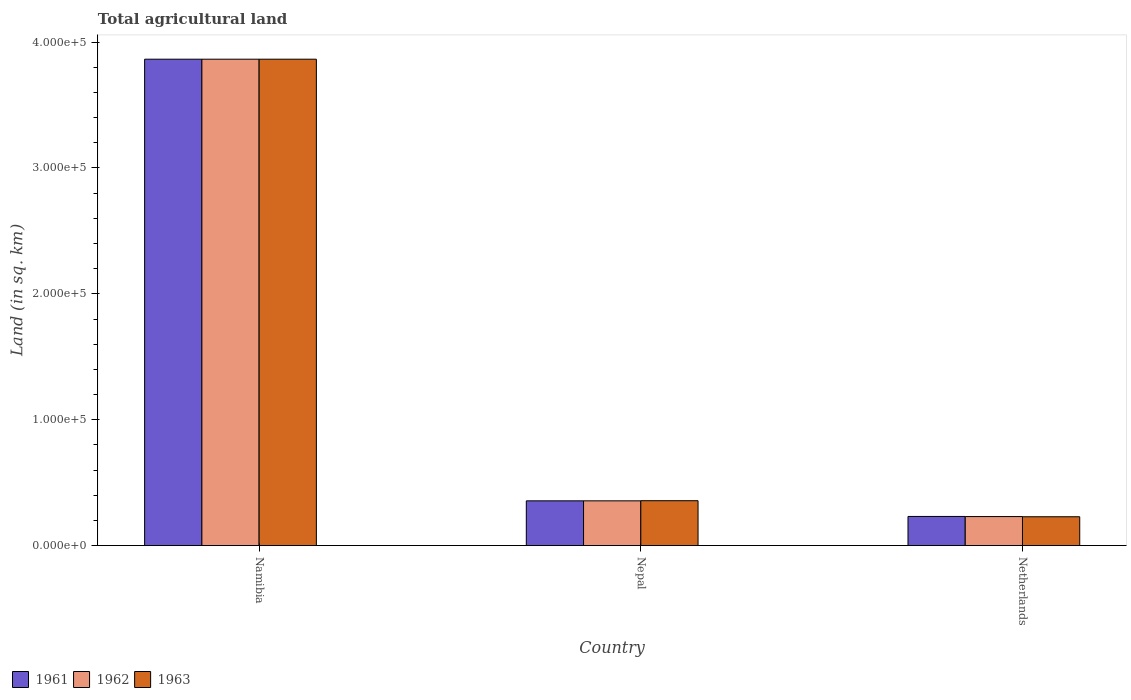How many different coloured bars are there?
Your answer should be compact. 3. How many groups of bars are there?
Your response must be concise. 3. Are the number of bars per tick equal to the number of legend labels?
Keep it short and to the point. Yes. Are the number of bars on each tick of the X-axis equal?
Give a very brief answer. Yes. How many bars are there on the 1st tick from the left?
Provide a succinct answer. 3. What is the label of the 1st group of bars from the left?
Give a very brief answer. Namibia. What is the total agricultural land in 1961 in Namibia?
Provide a succinct answer. 3.86e+05. Across all countries, what is the maximum total agricultural land in 1962?
Your answer should be compact. 3.86e+05. Across all countries, what is the minimum total agricultural land in 1961?
Your answer should be very brief. 2.31e+04. In which country was the total agricultural land in 1961 maximum?
Provide a short and direct response. Namibia. In which country was the total agricultural land in 1963 minimum?
Offer a very short reply. Netherlands. What is the total total agricultural land in 1961 in the graph?
Your response must be concise. 4.45e+05. What is the difference between the total agricultural land in 1962 in Namibia and that in Nepal?
Your answer should be very brief. 3.51e+05. What is the difference between the total agricultural land in 1963 in Nepal and the total agricultural land in 1962 in Namibia?
Provide a succinct answer. -3.51e+05. What is the average total agricultural land in 1961 per country?
Make the answer very short. 1.48e+05. In how many countries, is the total agricultural land in 1962 greater than 180000 sq.km?
Ensure brevity in your answer.  1. What is the ratio of the total agricultural land in 1961 in Namibia to that in Nepal?
Keep it short and to the point. 10.88. Is the total agricultural land in 1962 in Nepal less than that in Netherlands?
Ensure brevity in your answer.  No. Is the difference between the total agricultural land in 1961 in Namibia and Nepal greater than the difference between the total agricultural land in 1962 in Namibia and Nepal?
Your answer should be very brief. No. What is the difference between the highest and the second highest total agricultural land in 1962?
Give a very brief answer. -3.51e+05. What is the difference between the highest and the lowest total agricultural land in 1961?
Give a very brief answer. 3.63e+05. In how many countries, is the total agricultural land in 1963 greater than the average total agricultural land in 1963 taken over all countries?
Offer a very short reply. 1. Is the sum of the total agricultural land in 1961 in Nepal and Netherlands greater than the maximum total agricultural land in 1962 across all countries?
Make the answer very short. No. How many bars are there?
Your answer should be compact. 9. What is the difference between two consecutive major ticks on the Y-axis?
Your answer should be compact. 1.00e+05. How many legend labels are there?
Provide a succinct answer. 3. How are the legend labels stacked?
Ensure brevity in your answer.  Horizontal. What is the title of the graph?
Offer a terse response. Total agricultural land. Does "2011" appear as one of the legend labels in the graph?
Your answer should be compact. No. What is the label or title of the X-axis?
Make the answer very short. Country. What is the label or title of the Y-axis?
Your answer should be compact. Land (in sq. km). What is the Land (in sq. km) of 1961 in Namibia?
Ensure brevity in your answer.  3.86e+05. What is the Land (in sq. km) in 1962 in Namibia?
Keep it short and to the point. 3.86e+05. What is the Land (in sq. km) of 1963 in Namibia?
Provide a succinct answer. 3.86e+05. What is the Land (in sq. km) of 1961 in Nepal?
Provide a succinct answer. 3.55e+04. What is the Land (in sq. km) of 1962 in Nepal?
Your answer should be very brief. 3.55e+04. What is the Land (in sq. km) of 1963 in Nepal?
Offer a very short reply. 3.56e+04. What is the Land (in sq. km) in 1961 in Netherlands?
Your answer should be compact. 2.31e+04. What is the Land (in sq. km) in 1962 in Netherlands?
Make the answer very short. 2.30e+04. What is the Land (in sq. km) of 1963 in Netherlands?
Make the answer very short. 2.29e+04. Across all countries, what is the maximum Land (in sq. km) of 1961?
Offer a very short reply. 3.86e+05. Across all countries, what is the maximum Land (in sq. km) of 1962?
Your answer should be very brief. 3.86e+05. Across all countries, what is the maximum Land (in sq. km) in 1963?
Ensure brevity in your answer.  3.86e+05. Across all countries, what is the minimum Land (in sq. km) of 1961?
Ensure brevity in your answer.  2.31e+04. Across all countries, what is the minimum Land (in sq. km) in 1962?
Your response must be concise. 2.30e+04. Across all countries, what is the minimum Land (in sq. km) in 1963?
Your answer should be very brief. 2.29e+04. What is the total Land (in sq. km) of 1961 in the graph?
Make the answer very short. 4.45e+05. What is the total Land (in sq. km) in 1962 in the graph?
Your answer should be compact. 4.45e+05. What is the total Land (in sq. km) in 1963 in the graph?
Your answer should be compact. 4.45e+05. What is the difference between the Land (in sq. km) in 1961 in Namibia and that in Nepal?
Your response must be concise. 3.51e+05. What is the difference between the Land (in sq. km) of 1962 in Namibia and that in Nepal?
Your response must be concise. 3.51e+05. What is the difference between the Land (in sq. km) of 1963 in Namibia and that in Nepal?
Offer a terse response. 3.51e+05. What is the difference between the Land (in sq. km) in 1961 in Namibia and that in Netherlands?
Ensure brevity in your answer.  3.63e+05. What is the difference between the Land (in sq. km) of 1962 in Namibia and that in Netherlands?
Make the answer very short. 3.63e+05. What is the difference between the Land (in sq. km) in 1963 in Namibia and that in Netherlands?
Keep it short and to the point. 3.64e+05. What is the difference between the Land (in sq. km) in 1961 in Nepal and that in Netherlands?
Offer a terse response. 1.24e+04. What is the difference between the Land (in sq. km) of 1962 in Nepal and that in Netherlands?
Your response must be concise. 1.25e+04. What is the difference between the Land (in sq. km) in 1963 in Nepal and that in Netherlands?
Provide a succinct answer. 1.27e+04. What is the difference between the Land (in sq. km) of 1961 in Namibia and the Land (in sq. km) of 1962 in Nepal?
Your answer should be compact. 3.51e+05. What is the difference between the Land (in sq. km) of 1961 in Namibia and the Land (in sq. km) of 1963 in Nepal?
Give a very brief answer. 3.51e+05. What is the difference between the Land (in sq. km) in 1962 in Namibia and the Land (in sq. km) in 1963 in Nepal?
Your answer should be very brief. 3.51e+05. What is the difference between the Land (in sq. km) in 1961 in Namibia and the Land (in sq. km) in 1962 in Netherlands?
Keep it short and to the point. 3.63e+05. What is the difference between the Land (in sq. km) in 1961 in Namibia and the Land (in sq. km) in 1963 in Netherlands?
Keep it short and to the point. 3.64e+05. What is the difference between the Land (in sq. km) of 1962 in Namibia and the Land (in sq. km) of 1963 in Netherlands?
Keep it short and to the point. 3.64e+05. What is the difference between the Land (in sq. km) of 1961 in Nepal and the Land (in sq. km) of 1962 in Netherlands?
Provide a short and direct response. 1.25e+04. What is the difference between the Land (in sq. km) of 1961 in Nepal and the Land (in sq. km) of 1963 in Netherlands?
Your response must be concise. 1.26e+04. What is the difference between the Land (in sq. km) of 1962 in Nepal and the Land (in sq. km) of 1963 in Netherlands?
Provide a short and direct response. 1.26e+04. What is the average Land (in sq. km) in 1961 per country?
Keep it short and to the point. 1.48e+05. What is the average Land (in sq. km) in 1962 per country?
Keep it short and to the point. 1.48e+05. What is the average Land (in sq. km) of 1963 per country?
Your answer should be very brief. 1.48e+05. What is the difference between the Land (in sq. km) in 1961 and Land (in sq. km) in 1962 in Namibia?
Your answer should be very brief. 0. What is the difference between the Land (in sq. km) in 1961 and Land (in sq. km) in 1963 in Namibia?
Make the answer very short. 0. What is the difference between the Land (in sq. km) of 1962 and Land (in sq. km) of 1963 in Namibia?
Ensure brevity in your answer.  0. What is the difference between the Land (in sq. km) of 1961 and Land (in sq. km) of 1962 in Nepal?
Make the answer very short. 0. What is the difference between the Land (in sq. km) in 1961 and Land (in sq. km) in 1963 in Nepal?
Give a very brief answer. -100. What is the difference between the Land (in sq. km) in 1962 and Land (in sq. km) in 1963 in Nepal?
Your response must be concise. -100. What is the difference between the Land (in sq. km) in 1961 and Land (in sq. km) in 1962 in Netherlands?
Your answer should be compact. 110. What is the difference between the Land (in sq. km) in 1961 and Land (in sq. km) in 1963 in Netherlands?
Offer a terse response. 250. What is the difference between the Land (in sq. km) of 1962 and Land (in sq. km) of 1963 in Netherlands?
Your response must be concise. 140. What is the ratio of the Land (in sq. km) in 1961 in Namibia to that in Nepal?
Your response must be concise. 10.88. What is the ratio of the Land (in sq. km) in 1962 in Namibia to that in Nepal?
Ensure brevity in your answer.  10.88. What is the ratio of the Land (in sq. km) in 1963 in Namibia to that in Nepal?
Your response must be concise. 10.85. What is the ratio of the Land (in sq. km) in 1961 in Namibia to that in Netherlands?
Ensure brevity in your answer.  16.7. What is the ratio of the Land (in sq. km) of 1962 in Namibia to that in Netherlands?
Offer a very short reply. 16.78. What is the ratio of the Land (in sq. km) of 1963 in Namibia to that in Netherlands?
Keep it short and to the point. 16.88. What is the ratio of the Land (in sq. km) of 1961 in Nepal to that in Netherlands?
Keep it short and to the point. 1.54. What is the ratio of the Land (in sq. km) in 1962 in Nepal to that in Netherlands?
Make the answer very short. 1.54. What is the ratio of the Land (in sq. km) in 1963 in Nepal to that in Netherlands?
Keep it short and to the point. 1.56. What is the difference between the highest and the second highest Land (in sq. km) of 1961?
Provide a short and direct response. 3.51e+05. What is the difference between the highest and the second highest Land (in sq. km) in 1962?
Keep it short and to the point. 3.51e+05. What is the difference between the highest and the second highest Land (in sq. km) in 1963?
Keep it short and to the point. 3.51e+05. What is the difference between the highest and the lowest Land (in sq. km) of 1961?
Give a very brief answer. 3.63e+05. What is the difference between the highest and the lowest Land (in sq. km) of 1962?
Ensure brevity in your answer.  3.63e+05. What is the difference between the highest and the lowest Land (in sq. km) of 1963?
Offer a terse response. 3.64e+05. 